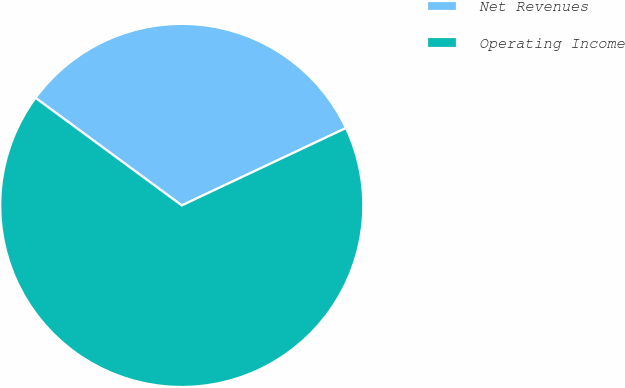<chart> <loc_0><loc_0><loc_500><loc_500><pie_chart><fcel>Net Revenues<fcel>Operating Income<nl><fcel>32.9%<fcel>67.1%<nl></chart> 